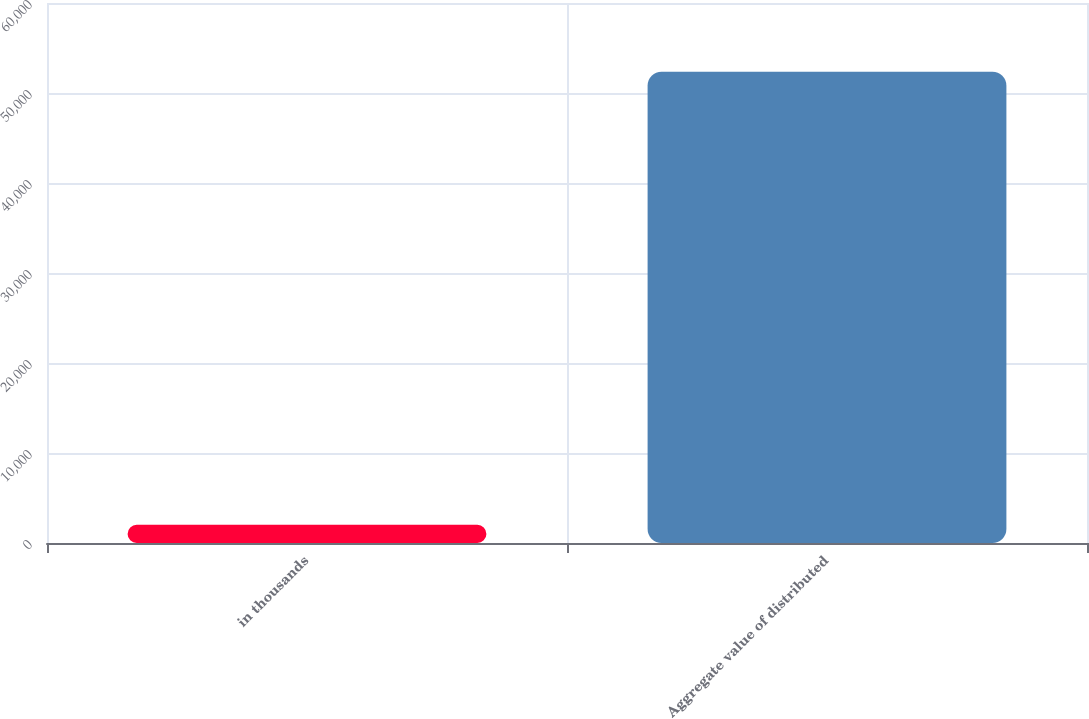<chart> <loc_0><loc_0><loc_500><loc_500><bar_chart><fcel>in thousands<fcel>Aggregate value of distributed<nl><fcel>2017<fcel>52368<nl></chart> 